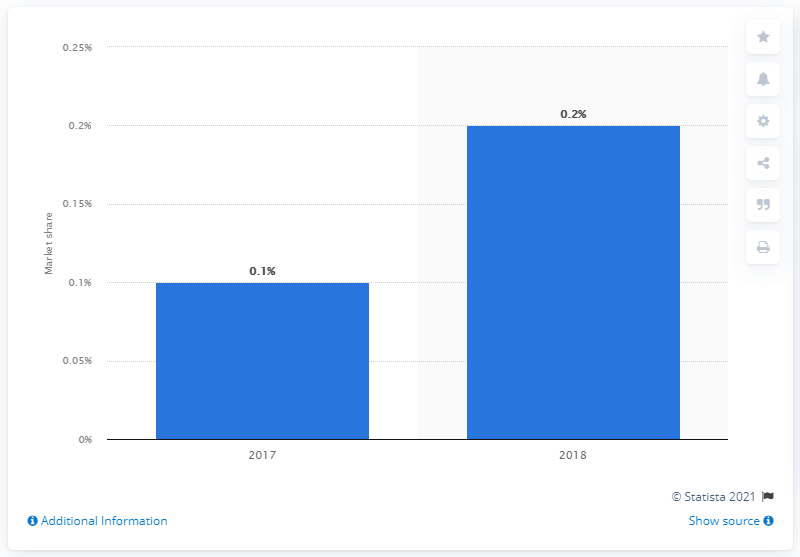Indicate a few pertinent items in this graphic. In 2018, Philip Morris accounted for approximately 0.2% of the global heated tobacco units market. 